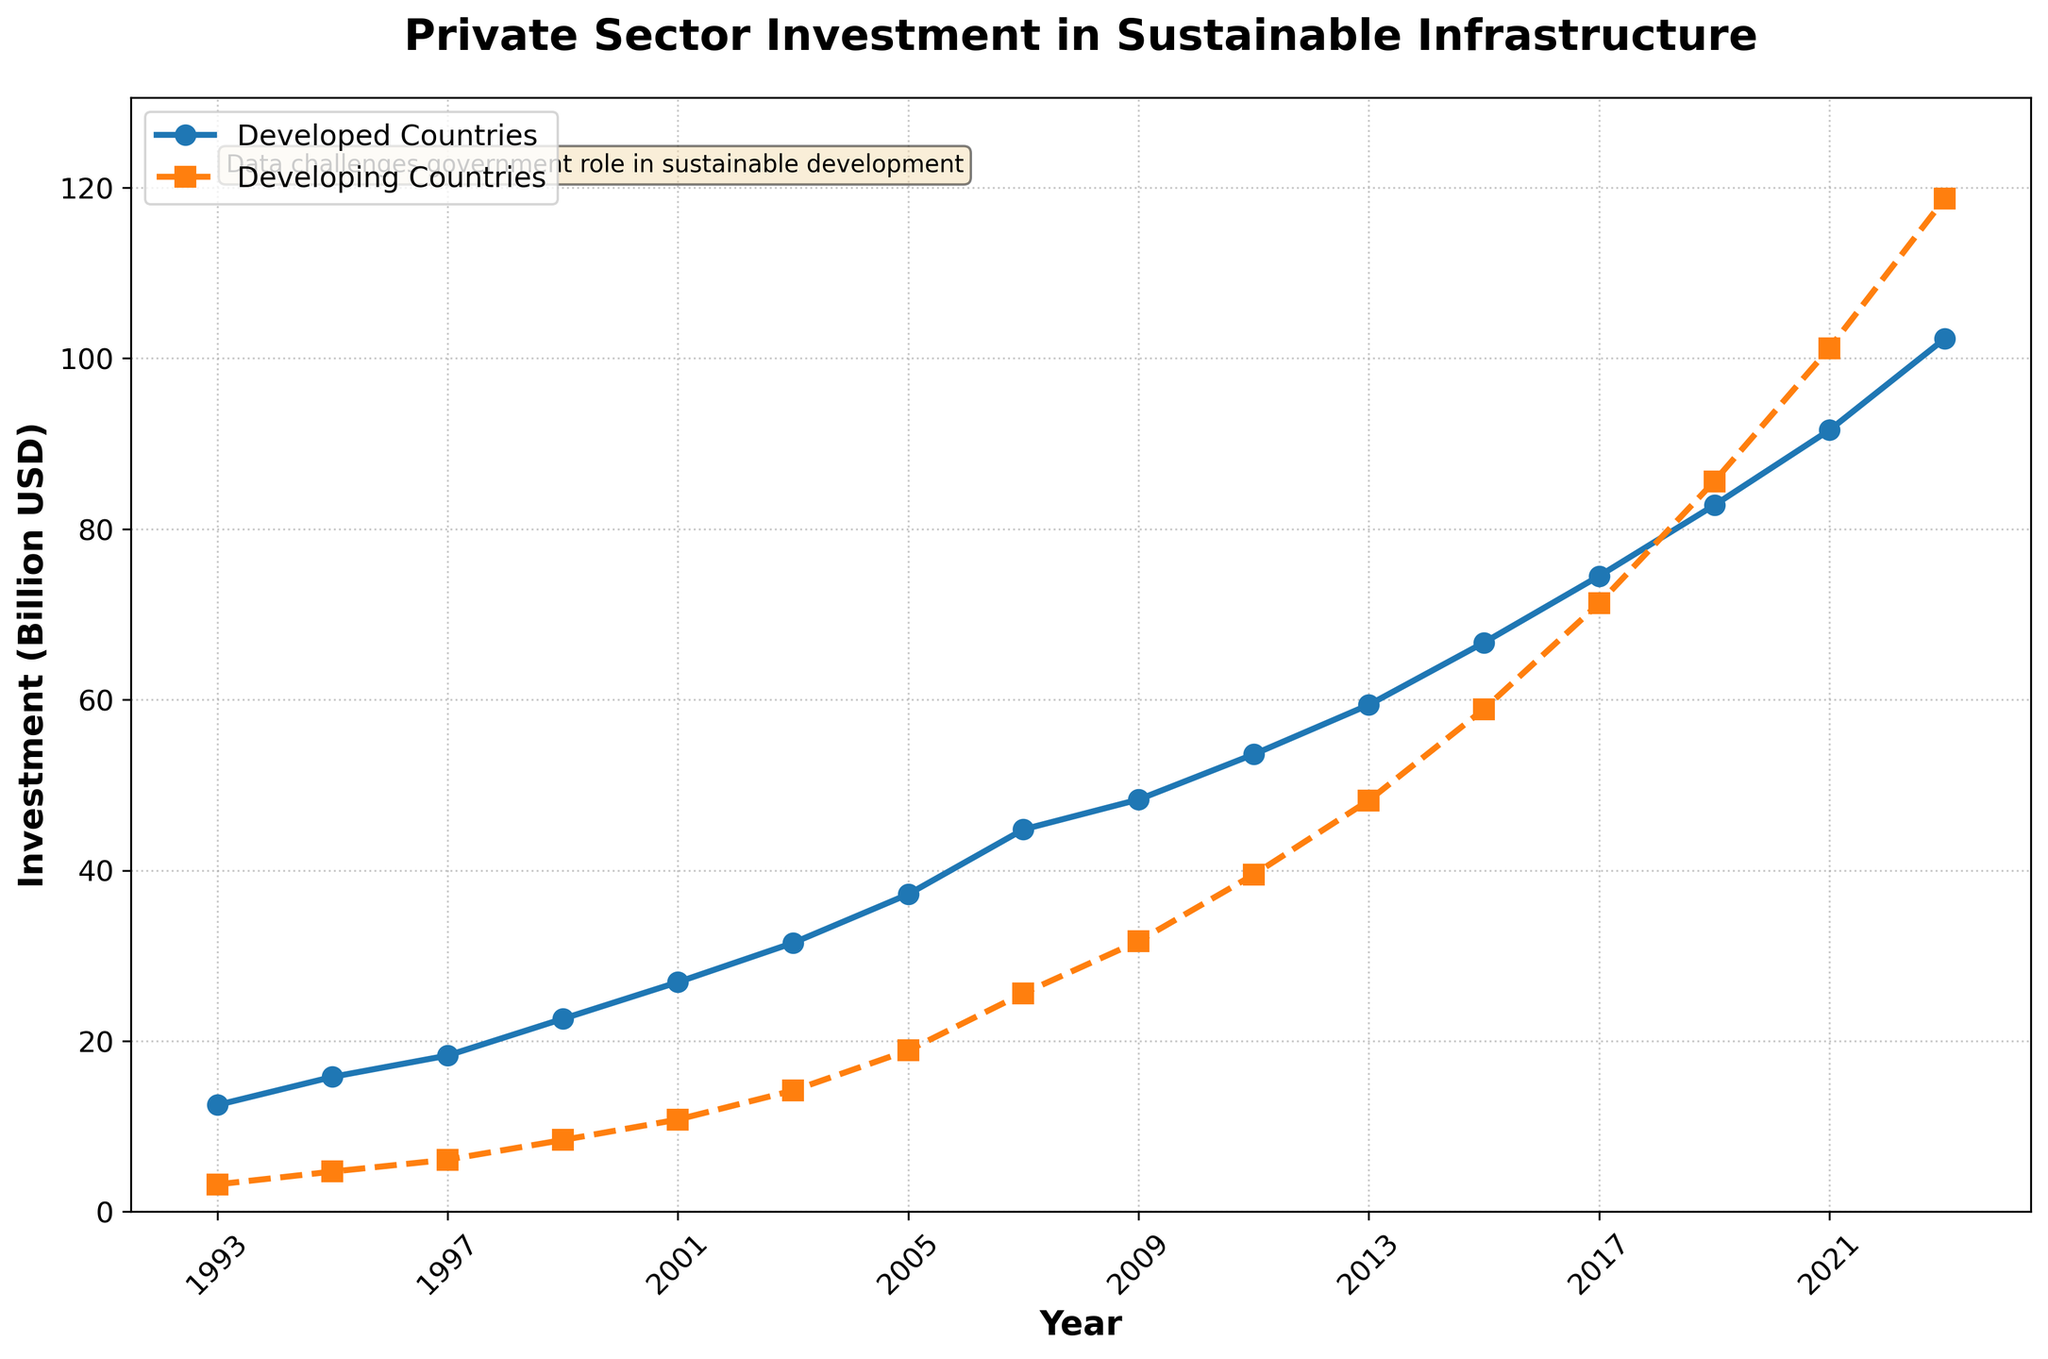How did the investment trends in developed and developing countries compare over the 30 years? To compare the trends, observe the two lines over the period. Both lines show an increasing trend, but the line representing developing countries starts to rise more sharply around 2009, eventually surpassing the investment in developed countries. This indicates that while both saw increases, developing countries experienced a more dramatic rise in investments in recent years.
Answer: Investments in both developed and developing countries increased, with developing countries' investments rising more sharply after 2009 In which year did private sector investment in developing countries surpass that in developed countries? To find this, look at where the orange dotted line (developing countries) crosses above the blue solid line (developed countries). This occurs between 2017 and 2019. Therefore, 2019 is the year developing countries' investment surpassed developed countries' investment.
Answer: 2019 What was the investment difference between developed and developing countries in 2023? First, locate the investment values for 2023: developed countries at 102.3 billion USD and developing countries at 118.7 billion USD. Subtract the smaller value from the larger one: 118.7 - 102.3 = 16.4 billion USD.
Answer: 16.4 billion USD What is the average investment in developing countries from 1993 to 2023? Add the investment values for developing countries and divide by the number of years (16). Sum: 3.2 + 4.7 + 6.1 + 8.4 + 10.8 + 14.2 + 18.9 + 25.6 + 31.7 + 39.5 + 48.2 + 58.9 + 71.3 + 85.6 + 101.2 + 118.7 = 648.0. The average is 648.0 / 16 = 40.5 billion USD.
Answer: 40.5 billion USD Which country category had the highest investment in sustainable infrastructure in 2021? Look at the investment values for 2021. Developed countries had 91.6 billion USD, while developing countries had 101.2 billion USD. The latter is higher.
Answer: Developing countries How much did private sector investment in developed countries increase from 1993 to 2023? Subtract the 1993 value from the 2023 value for developed countries: 102.3 - 12.5 = 89.8 billion USD.
Answer: 89.8 billion USD Between 2007 and 2009, which country category saw a larger increase in sustainable infrastructure investment? Calculate the increase for both categories. Developed: 48.3 (2009) - 44.8 (2007) = 3.5 billion USD. Developing: 31.7 (2009) - 25.6 (2007) = 6.1 billion USD. Therefore, developing countries saw a larger increase.
Answer: Developing countries What is the color and line style used to represent investments in developing countries? Identify the visual characteristics of the line representing developing countries. It is orange and dashed.
Answer: Orange and dashed Overall, how would you describe the trend in private sector investments for both developed and developing countries? Observe the general direction and slope of both lines: both are upward throughout the 30 years, indicating a consistent increase in private sector investments in sustainable infrastructure for both developed and developing countries.
Answer: Upward trend for both 